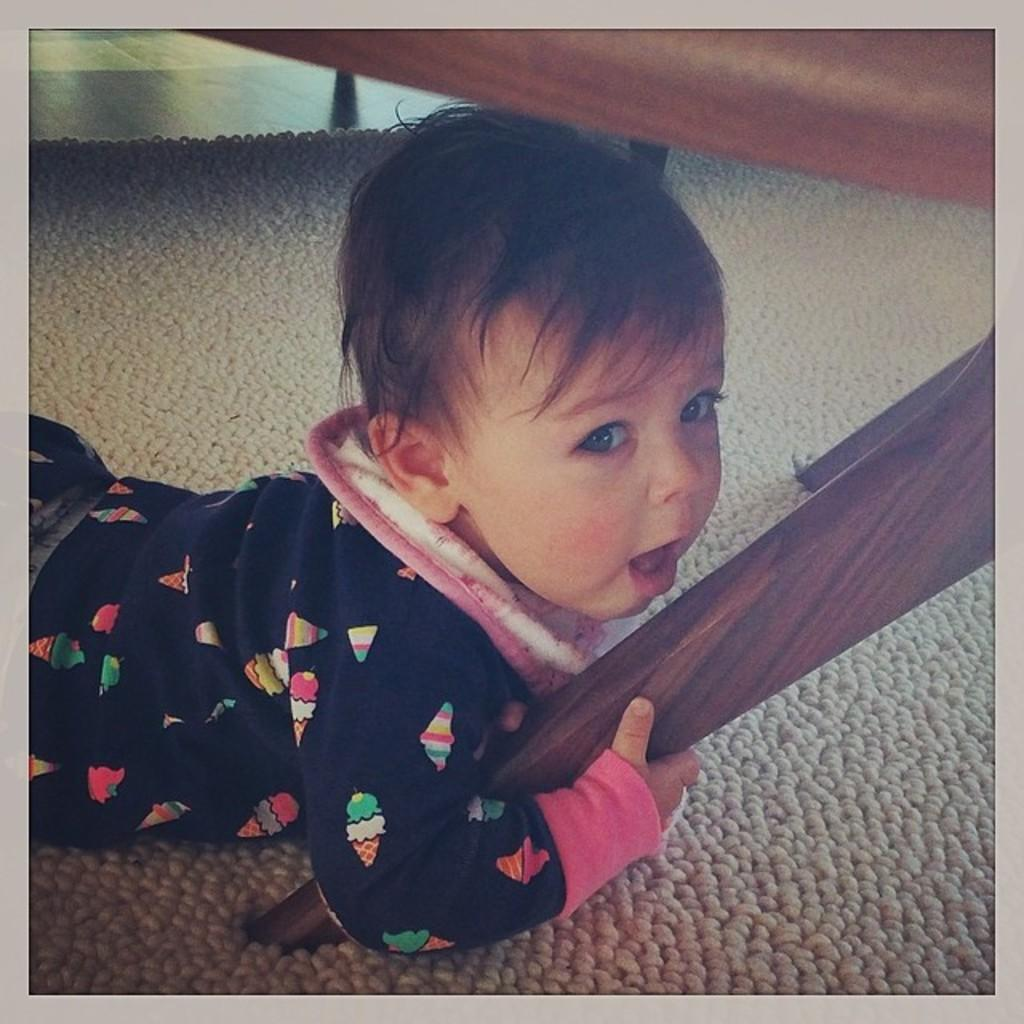What is the main subject of the image? The main subject of the image is a baby. What is the baby doing in the image? The baby is lying down. What is the baby holding in the image? The baby is holding a brown color object. What is present beneath the baby in the image? There is a floor mat in the image. What type of soap is the baby using in the image? There is no soap present in the image; the baby is holding a brown color object. What activity is the baby participating in during recess in the image? The image does not depict a recess or any specific activity; it simply shows a baby lying down and holding a brown color object. 